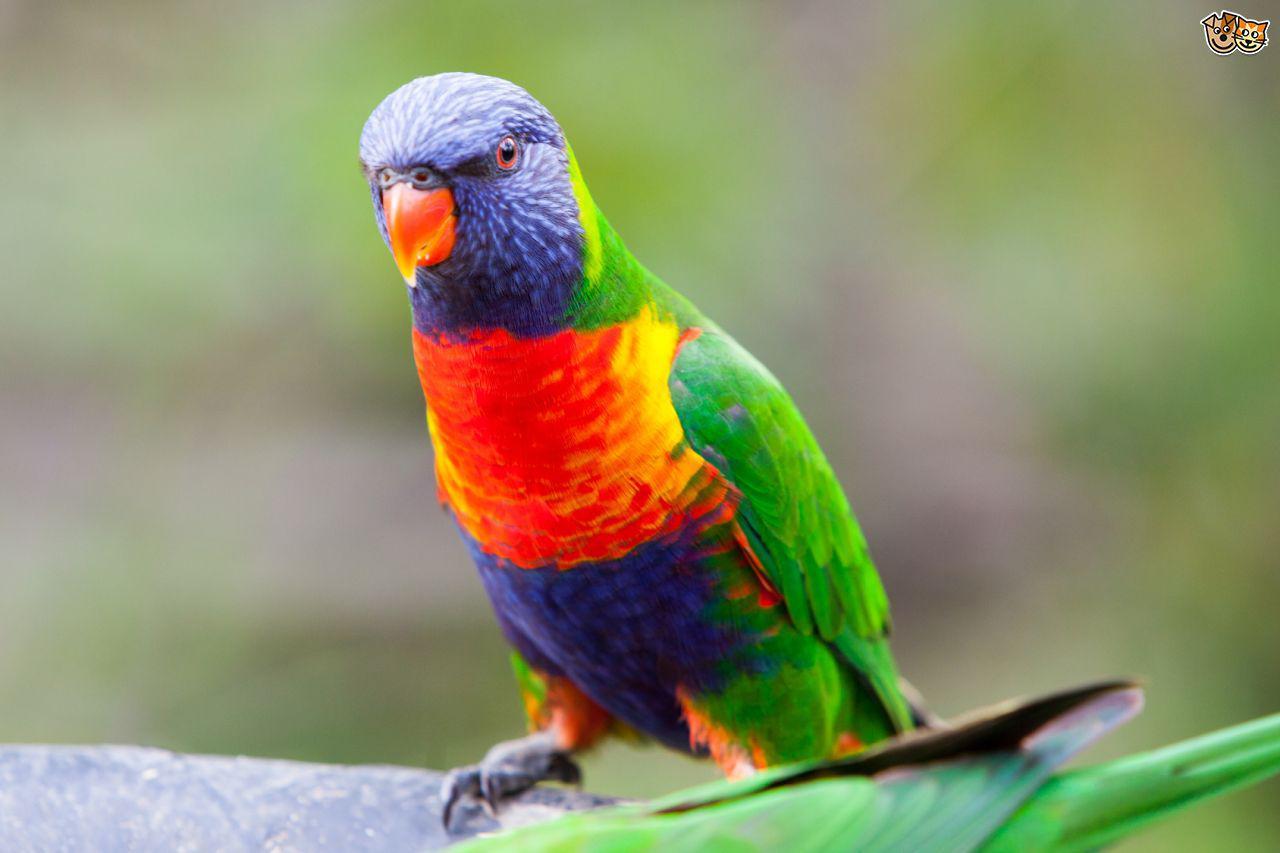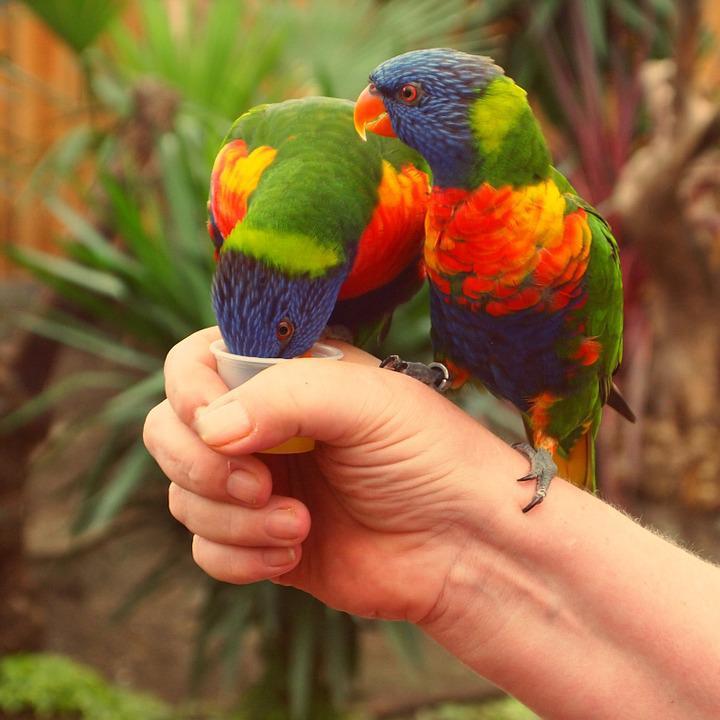The first image is the image on the left, the second image is the image on the right. For the images displayed, is the sentence "There are two birds in the image on the right." factually correct? Answer yes or no. Yes. 